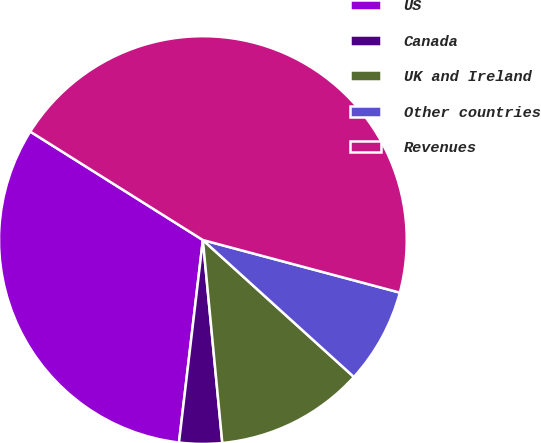<chart> <loc_0><loc_0><loc_500><loc_500><pie_chart><fcel>US<fcel>Canada<fcel>UK and Ireland<fcel>Other countries<fcel>Revenues<nl><fcel>32.06%<fcel>3.39%<fcel>11.76%<fcel>7.57%<fcel>45.23%<nl></chart> 